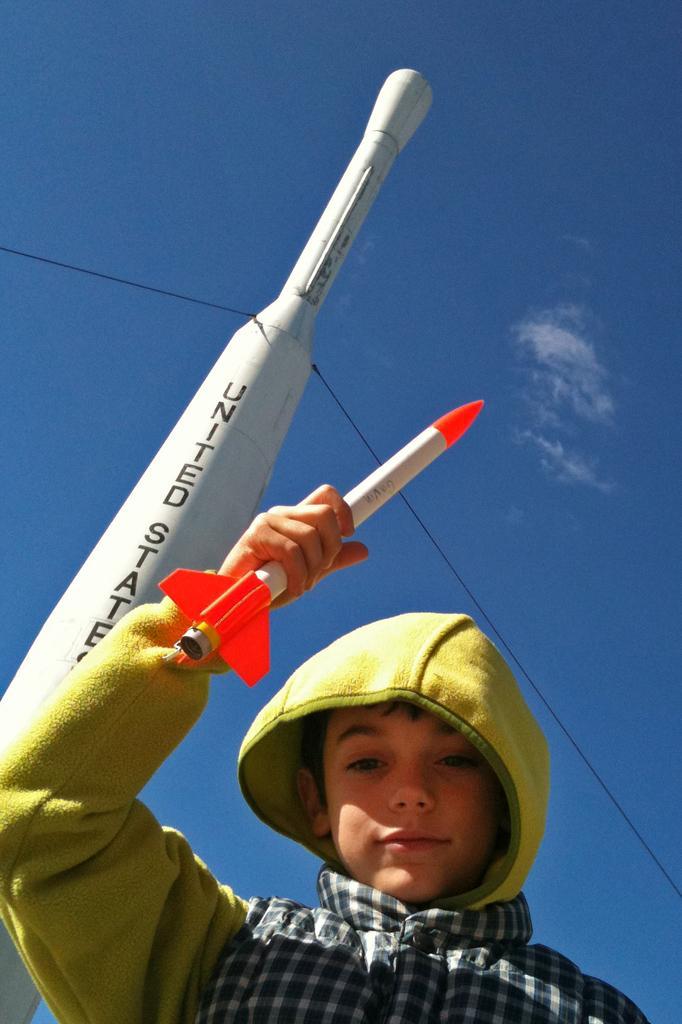Describe this image in one or two sentences. In this image there is a boy standing and holding a toy rocket. In the background there is an object which is white in colour with some text written on it and there is a wire which is black in colour. 